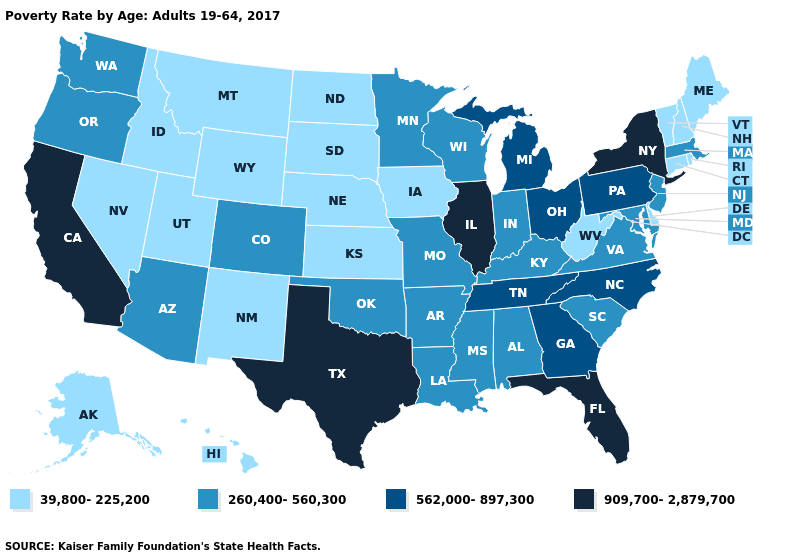Does the map have missing data?
Concise answer only. No. What is the highest value in the MidWest ?
Keep it brief. 909,700-2,879,700. Name the states that have a value in the range 39,800-225,200?
Quick response, please. Alaska, Connecticut, Delaware, Hawaii, Idaho, Iowa, Kansas, Maine, Montana, Nebraska, Nevada, New Hampshire, New Mexico, North Dakota, Rhode Island, South Dakota, Utah, Vermont, West Virginia, Wyoming. What is the lowest value in states that border Colorado?
Keep it brief. 39,800-225,200. Name the states that have a value in the range 909,700-2,879,700?
Keep it brief. California, Florida, Illinois, New York, Texas. What is the value of Maryland?
Write a very short answer. 260,400-560,300. What is the value of Connecticut?
Quick response, please. 39,800-225,200. What is the lowest value in the South?
Short answer required. 39,800-225,200. Name the states that have a value in the range 260,400-560,300?
Write a very short answer. Alabama, Arizona, Arkansas, Colorado, Indiana, Kentucky, Louisiana, Maryland, Massachusetts, Minnesota, Mississippi, Missouri, New Jersey, Oklahoma, Oregon, South Carolina, Virginia, Washington, Wisconsin. Name the states that have a value in the range 562,000-897,300?
Quick response, please. Georgia, Michigan, North Carolina, Ohio, Pennsylvania, Tennessee. What is the value of South Dakota?
Short answer required. 39,800-225,200. What is the highest value in states that border Vermont?
Concise answer only. 909,700-2,879,700. What is the lowest value in states that border California?
Be succinct. 39,800-225,200. Name the states that have a value in the range 909,700-2,879,700?
Keep it brief. California, Florida, Illinois, New York, Texas. 